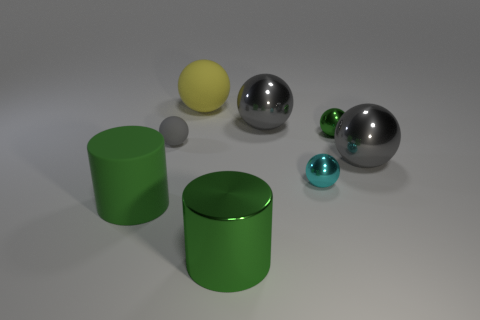Are there fewer big gray things in front of the large green rubber object than big gray metallic spheres that are right of the big matte ball?
Make the answer very short. Yes. Do the yellow ball and the gray rubber sphere have the same size?
Keep it short and to the point. No. What is the shape of the big thing that is both in front of the large yellow sphere and behind the small gray matte object?
Offer a very short reply. Sphere. What number of large purple cylinders are the same material as the tiny cyan object?
Provide a short and direct response. 0. There is a gray sphere behind the tiny gray object; how many large shiny balls are behind it?
Your answer should be very brief. 0. What shape is the big green object that is behind the object in front of the green cylinder that is on the left side of the big green metal object?
Make the answer very short. Cylinder. There is a rubber cylinder that is the same color as the big shiny cylinder; what size is it?
Your response must be concise. Large. How many objects are metallic balls or small yellow metallic cylinders?
Give a very brief answer. 4. There is a metallic thing that is the same size as the green shiny ball; what color is it?
Provide a short and direct response. Cyan. Is the shape of the tiny green object the same as the object that is in front of the big matte cylinder?
Your answer should be compact. No. 